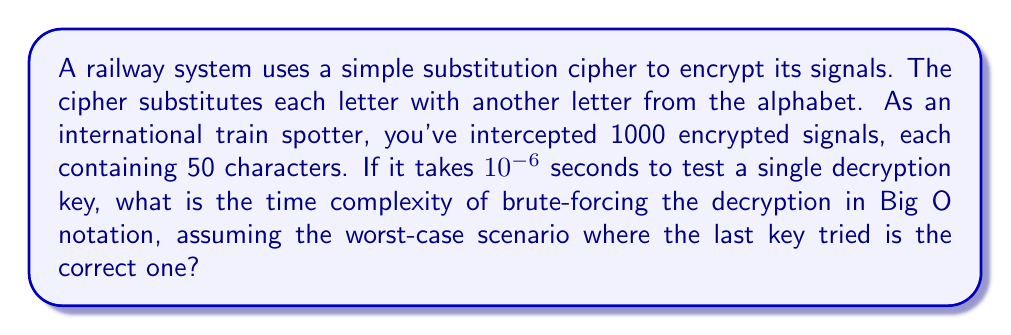Can you solve this math problem? Let's break this down step-by-step:

1) In a simple substitution cipher, there are 26! possible keys (permutations of the 26 letters in the alphabet).

2) The number of keys to test is therefore $26! = 4.03 \times 10^{26}$.

3) For each key, we need to:
   a) Apply the key to each of the 1000 messages
   b) For each message, we decrypt 50 characters

4) So, for each key, we perform $1000 \times 50 = 50,000$ decryptions

5) The time to test a single key is therefore:
   $50,000 \times 10^{-6} = 0.05$ seconds

6) The total time to test all keys in the worst case is:
   $4.03 \times 10^{26} \times 0.05 = 2.015 \times 10^{25}$ seconds

7) In Big O notation, we ignore constant factors and lower-order terms. The dominating factor here is $26!$, which is $O(n!)$ where $n$ is the size of the alphabet.

8) Therefore, the time complexity in Big O notation is $O(n!)$, where $n = 26$.
Answer: $O(n!)$, where $n = 26$ 